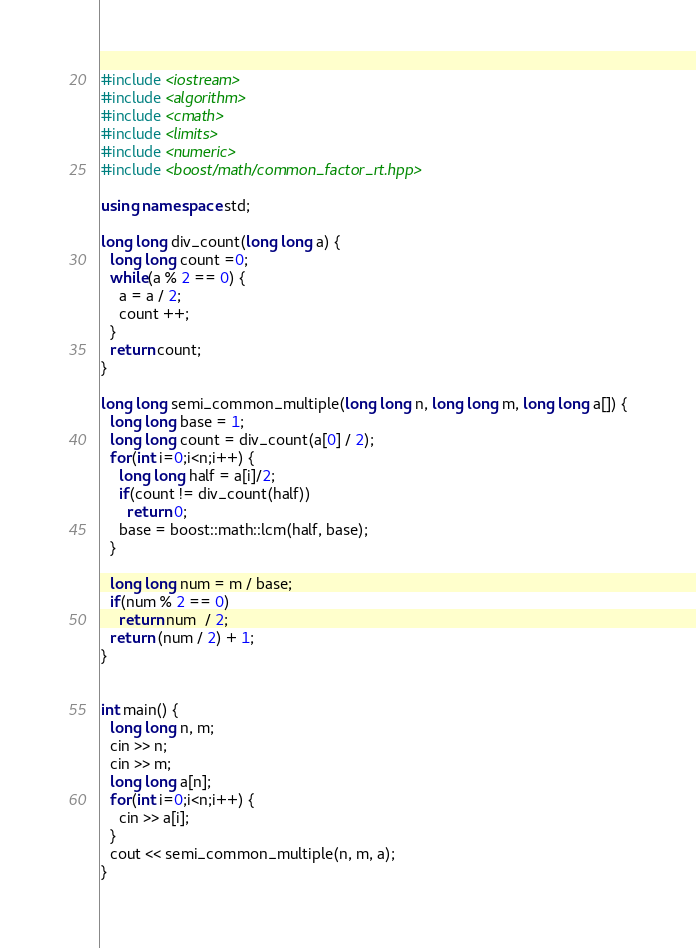Convert code to text. <code><loc_0><loc_0><loc_500><loc_500><_C++_>#include <iostream>
#include <algorithm>
#include <cmath>
#include <limits>
#include <numeric>
#include <boost/math/common_factor_rt.hpp>

using namespace std;

long long div_count(long long a) {
  long long count =0;
  while(a % 2 == 0) {
    a = a / 2;
    count ++;
  }
  return count;
}

long long semi_common_multiple(long long n, long long m, long long a[]) {
  long long base = 1;
  long long count = div_count(a[0] / 2);
  for(int i=0;i<n;i++) {
    long long half = a[i]/2;
    if(count != div_count(half))
      return 0;
    base = boost::math::lcm(half, base);
  }

  long long num = m / base; 
  if(num % 2 == 0)
    return num  / 2;
  return (num / 2) + 1;
}


int main() {
  long long n, m;
  cin >> n;
  cin >> m;
  long long a[n];
  for(int i=0;i<n;i++) {
    cin >> a[i];
  }
  cout << semi_common_multiple(n, m, a);
}
</code> 